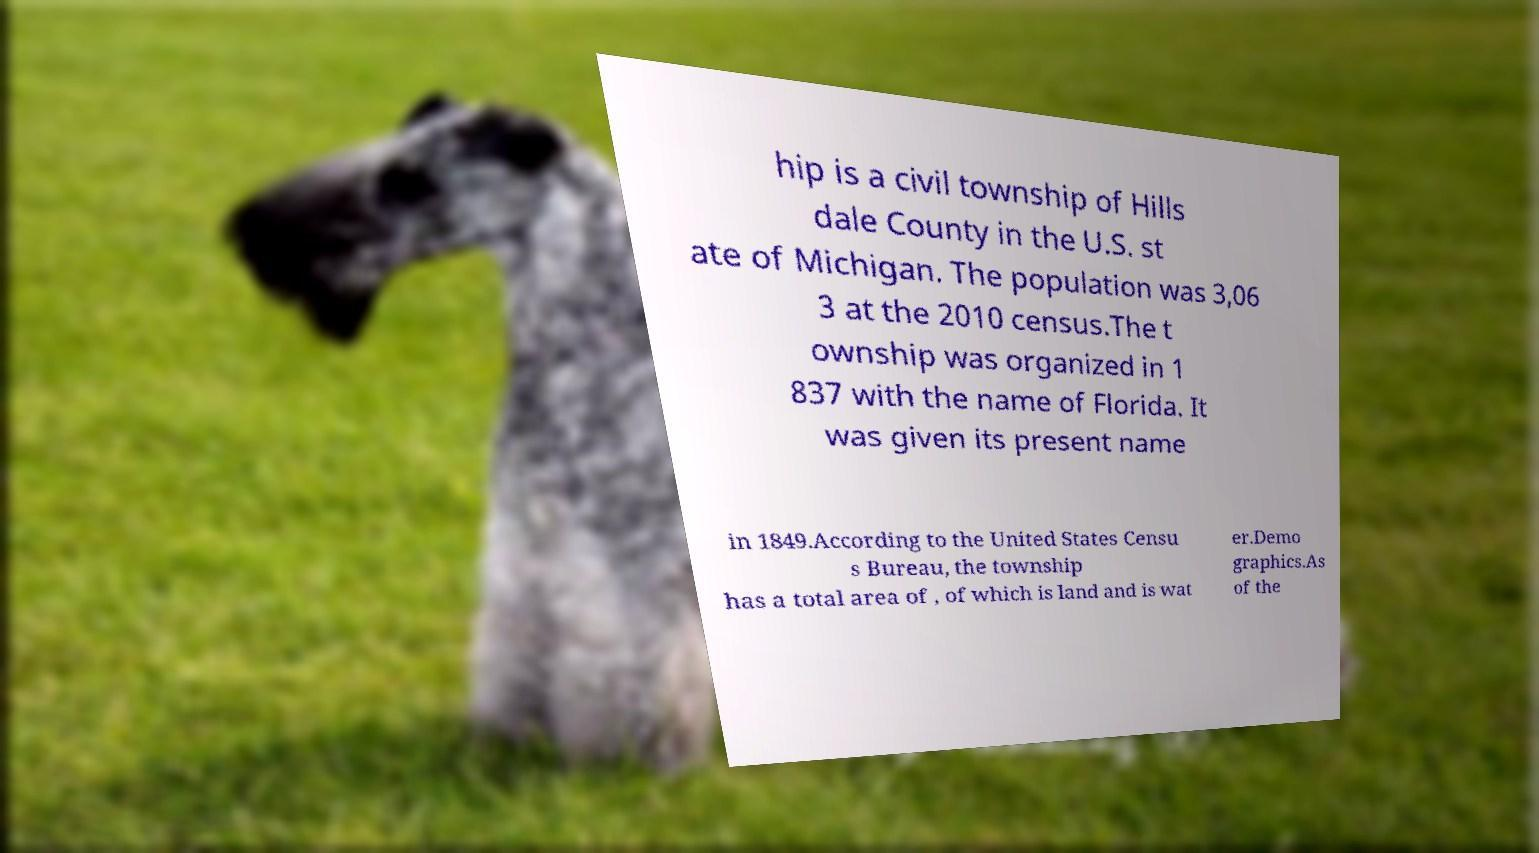What messages or text are displayed in this image? I need them in a readable, typed format. hip is a civil township of Hills dale County in the U.S. st ate of Michigan. The population was 3,06 3 at the 2010 census.The t ownship was organized in 1 837 with the name of Florida. It was given its present name in 1849.According to the United States Censu s Bureau, the township has a total area of , of which is land and is wat er.Demo graphics.As of the 